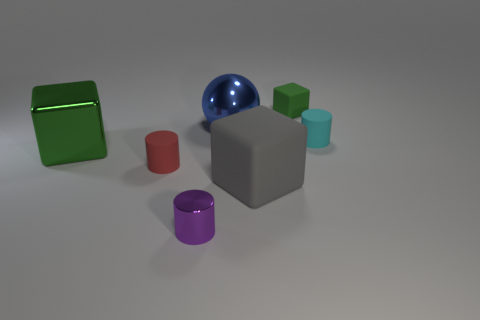Is there a large red object of the same shape as the large gray rubber thing?
Your answer should be compact. No. There is a rubber block that is in front of the tiny matte cylinder right of the big blue metallic ball; what is its color?
Offer a terse response. Gray. Is the number of small metallic things greater than the number of rubber things?
Your response must be concise. No. What number of shiny things are the same size as the cyan matte thing?
Offer a terse response. 1. Do the blue thing and the large green cube that is to the left of the big shiny ball have the same material?
Make the answer very short. Yes. Are there fewer matte objects than big red matte spheres?
Your answer should be very brief. No. Is there any other thing of the same color as the sphere?
Give a very brief answer. No. There is a small red object that is made of the same material as the small green thing; what shape is it?
Offer a very short reply. Cylinder. There is a tiny cylinder in front of the large block that is on the right side of the purple cylinder; how many green blocks are left of it?
Give a very brief answer. 1. There is a object that is to the right of the green shiny thing and to the left of the metallic cylinder; what is its shape?
Ensure brevity in your answer.  Cylinder. 